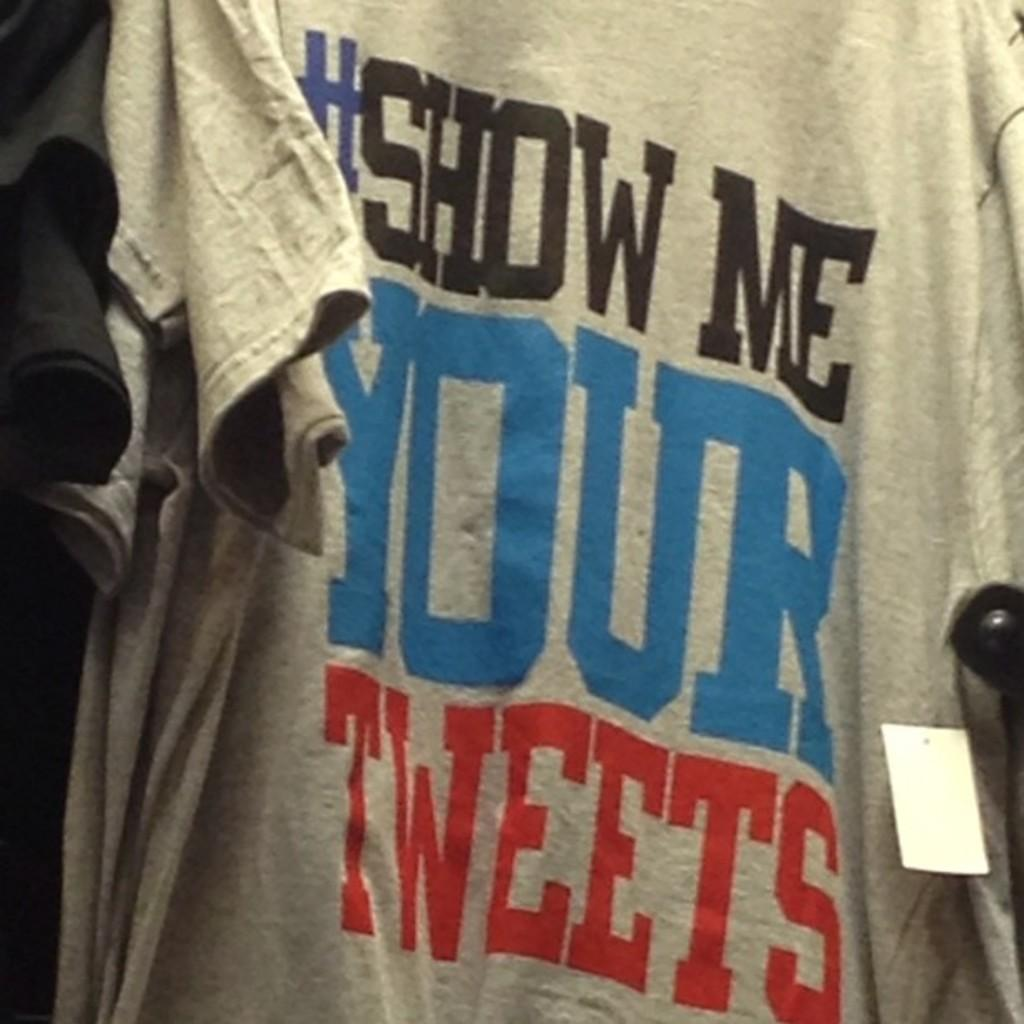Provide a one-sentence caption for the provided image. A gray #Show me your tweets t-shirt hanging in a store. 